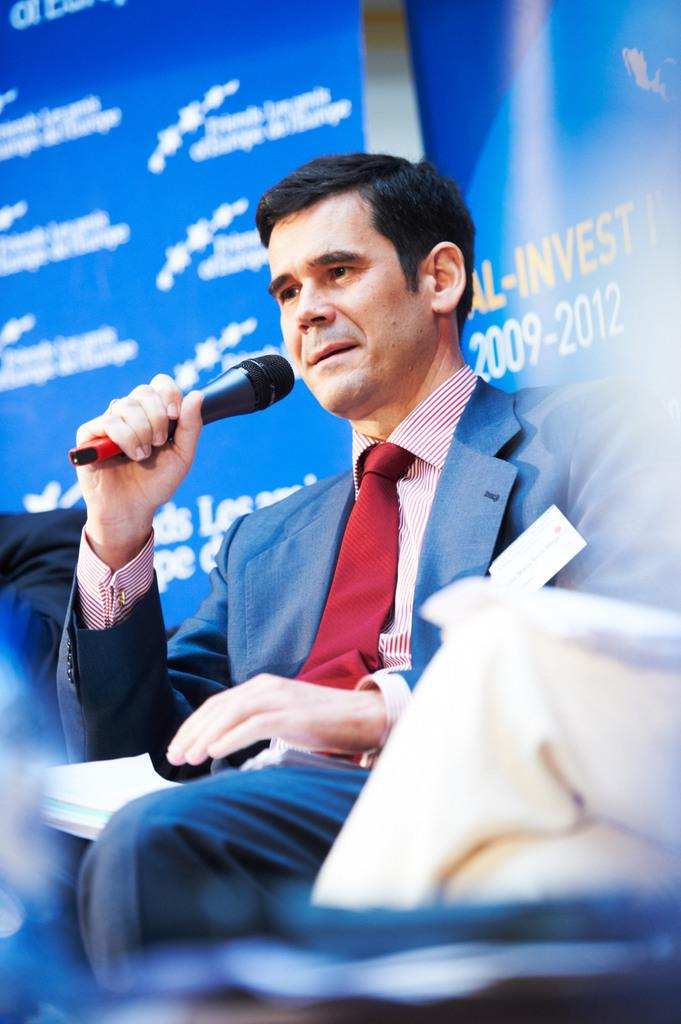Who or what is the main subject in the image? There is a person in the image. What is the person doing in the image? The person is sitting on a chair and holding a microphone. Are there any additional elements in the image besides the person? Yes, there are banners visible in the image. What type of furniture is the person eating breakfast on in the image? There is no furniture or breakfast present in the image; it only features a person sitting on a chair and holding a microphone. What is the person standing on the top of in the image? There is no indication of the person standing on anything in the image; they are sitting on a chair. 